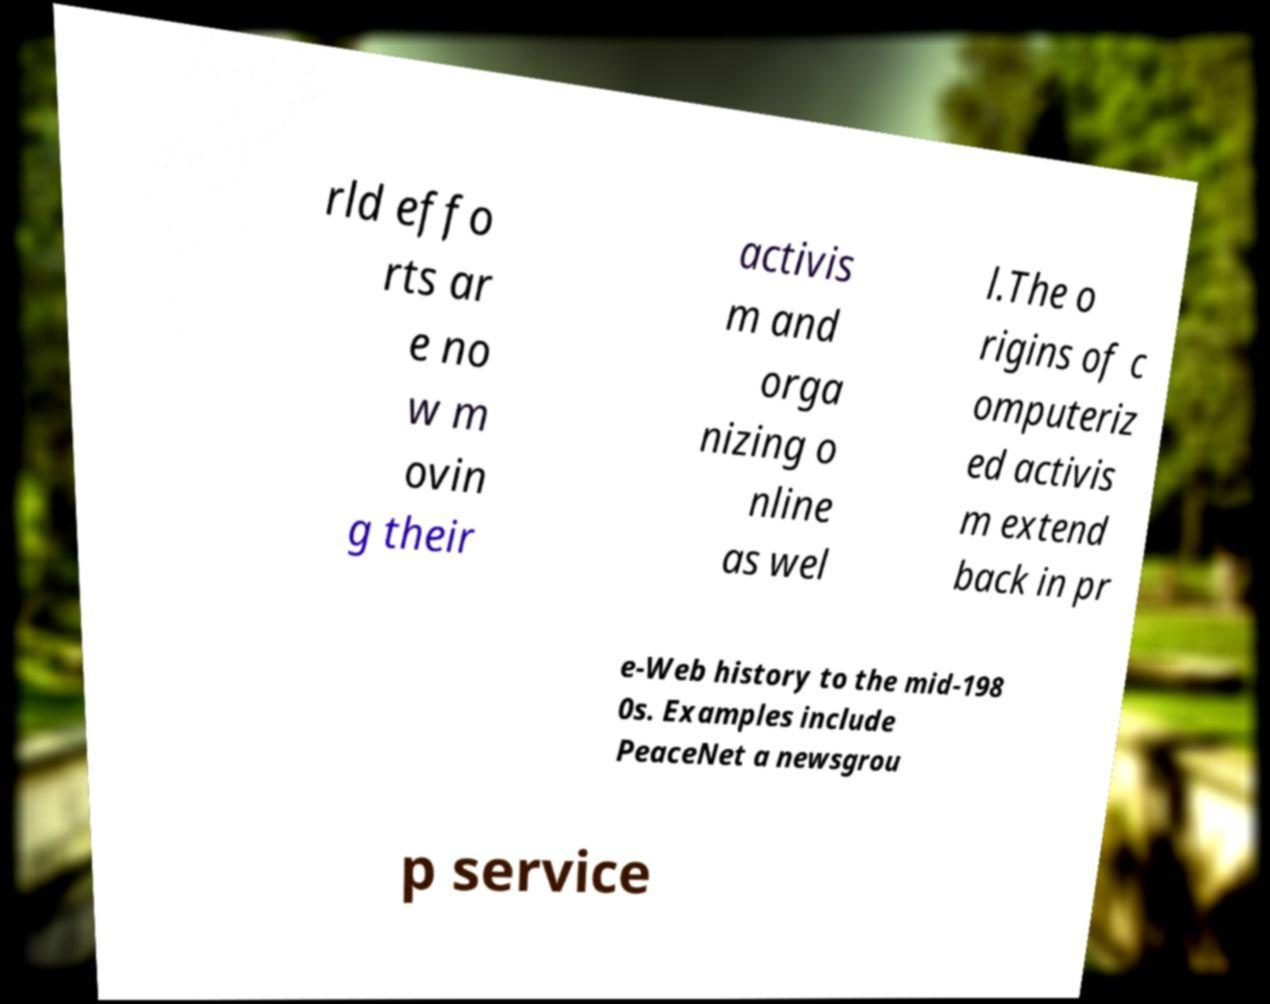What messages or text are displayed in this image? I need them in a readable, typed format. rld effo rts ar e no w m ovin g their activis m and orga nizing o nline as wel l.The o rigins of c omputeriz ed activis m extend back in pr e-Web history to the mid-198 0s. Examples include PeaceNet a newsgrou p service 